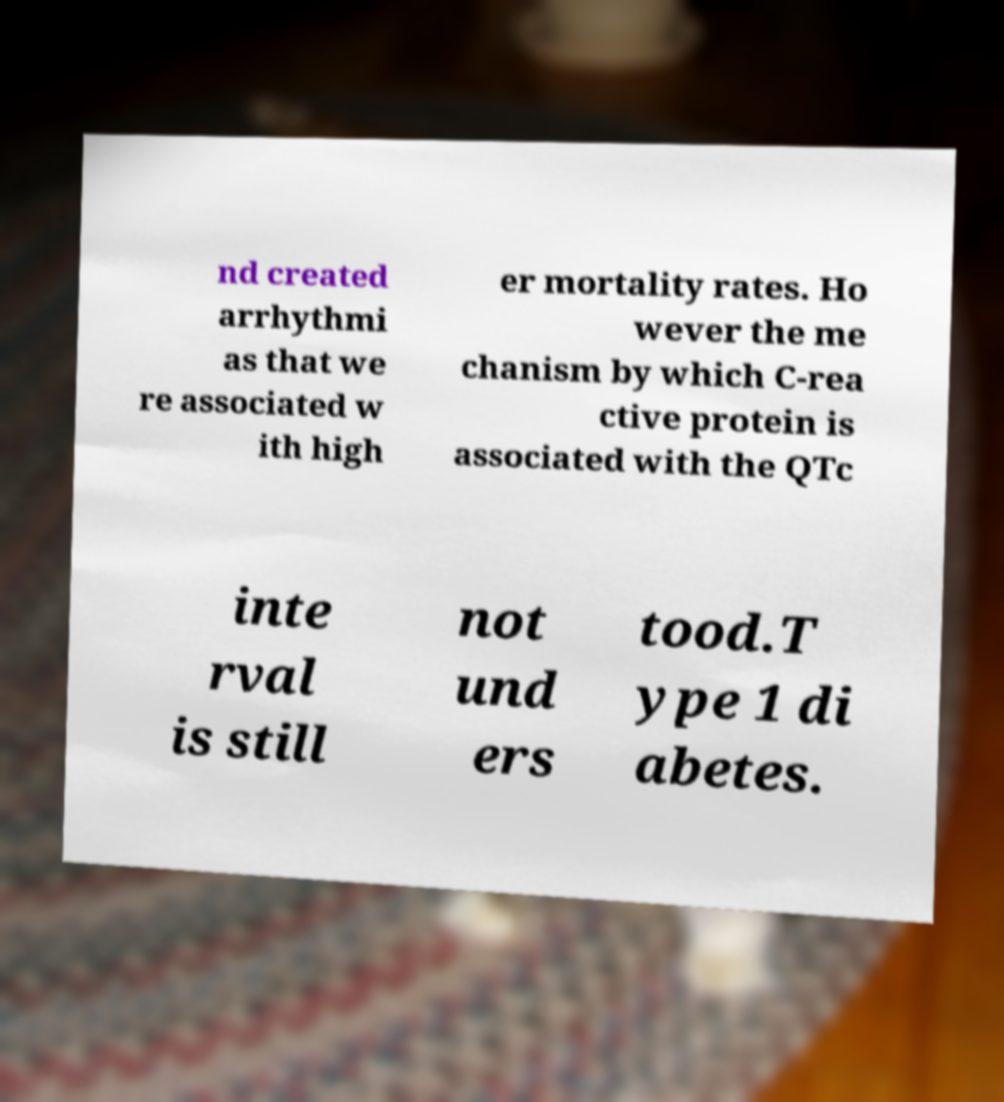Can you accurately transcribe the text from the provided image for me? nd created arrhythmi as that we re associated w ith high er mortality rates. Ho wever the me chanism by which C-rea ctive protein is associated with the QTc inte rval is still not und ers tood.T ype 1 di abetes. 